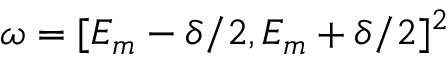Convert formula to latex. <formula><loc_0><loc_0><loc_500><loc_500>\omega = [ E _ { m } - \delta / 2 , E _ { m } + \delta / 2 ] ^ { 2 }</formula> 